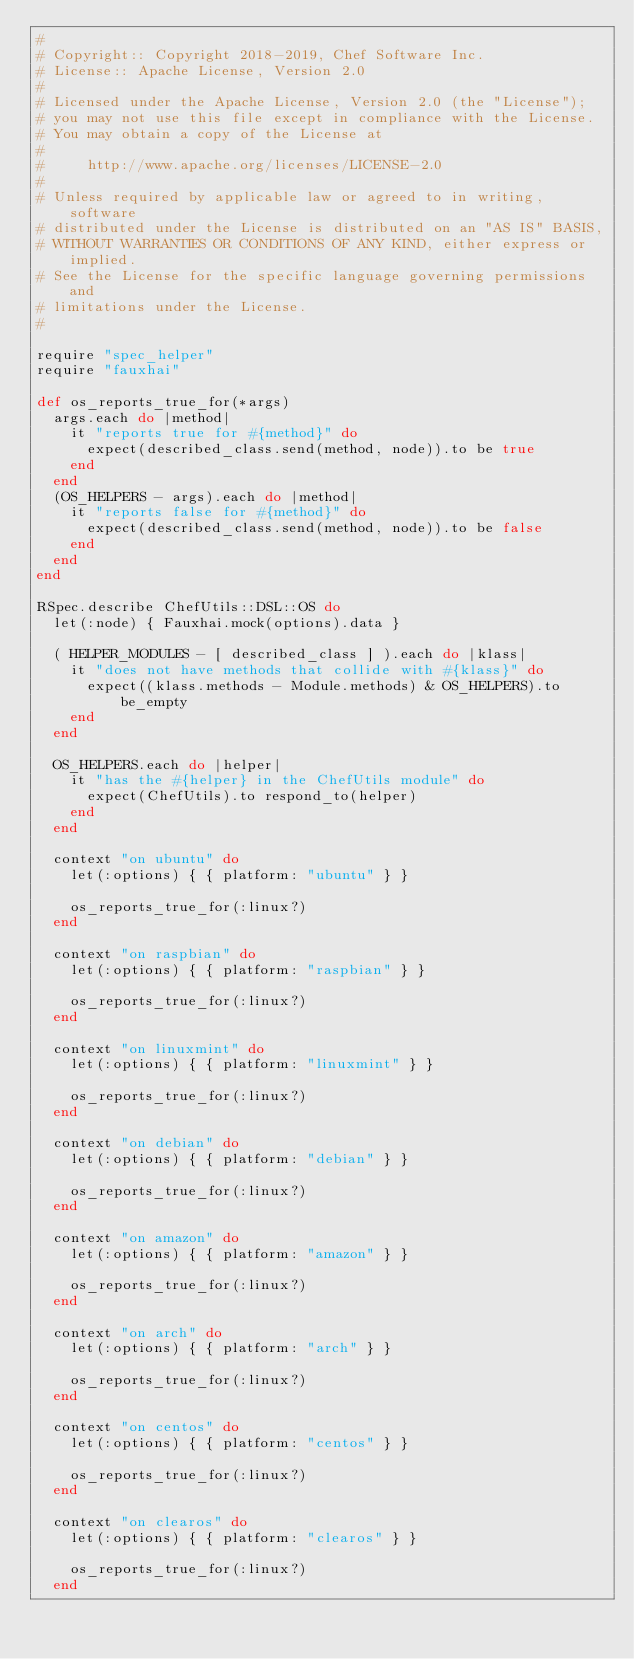Convert code to text. <code><loc_0><loc_0><loc_500><loc_500><_Ruby_>#
# Copyright:: Copyright 2018-2019, Chef Software Inc.
# License:: Apache License, Version 2.0
#
# Licensed under the Apache License, Version 2.0 (the "License");
# you may not use this file except in compliance with the License.
# You may obtain a copy of the License at
#
#     http://www.apache.org/licenses/LICENSE-2.0
#
# Unless required by applicable law or agreed to in writing, software
# distributed under the License is distributed on an "AS IS" BASIS,
# WITHOUT WARRANTIES OR CONDITIONS OF ANY KIND, either express or implied.
# See the License for the specific language governing permissions and
# limitations under the License.
#

require "spec_helper"
require "fauxhai"

def os_reports_true_for(*args)
  args.each do |method|
    it "reports true for #{method}" do
      expect(described_class.send(method, node)).to be true
    end
  end
  (OS_HELPERS - args).each do |method|
    it "reports false for #{method}" do
      expect(described_class.send(method, node)).to be false
    end
  end
end

RSpec.describe ChefUtils::DSL::OS do
  let(:node) { Fauxhai.mock(options).data }

  ( HELPER_MODULES - [ described_class ] ).each do |klass|
    it "does not have methods that collide with #{klass}" do
      expect((klass.methods - Module.methods) & OS_HELPERS).to be_empty
    end
  end

  OS_HELPERS.each do |helper|
    it "has the #{helper} in the ChefUtils module" do
      expect(ChefUtils).to respond_to(helper)
    end
  end

  context "on ubuntu" do
    let(:options) { { platform: "ubuntu" } }

    os_reports_true_for(:linux?)
  end

  context "on raspbian" do
    let(:options) { { platform: "raspbian" } }

    os_reports_true_for(:linux?)
  end

  context "on linuxmint" do
    let(:options) { { platform: "linuxmint" } }

    os_reports_true_for(:linux?)
  end

  context "on debian" do
    let(:options) { { platform: "debian" } }

    os_reports_true_for(:linux?)
  end

  context "on amazon" do
    let(:options) { { platform: "amazon" } }

    os_reports_true_for(:linux?)
  end

  context "on arch" do
    let(:options) { { platform: "arch" } }

    os_reports_true_for(:linux?)
  end

  context "on centos" do
    let(:options) { { platform: "centos" } }

    os_reports_true_for(:linux?)
  end

  context "on clearos" do
    let(:options) { { platform: "clearos" } }

    os_reports_true_for(:linux?)
  end
</code> 